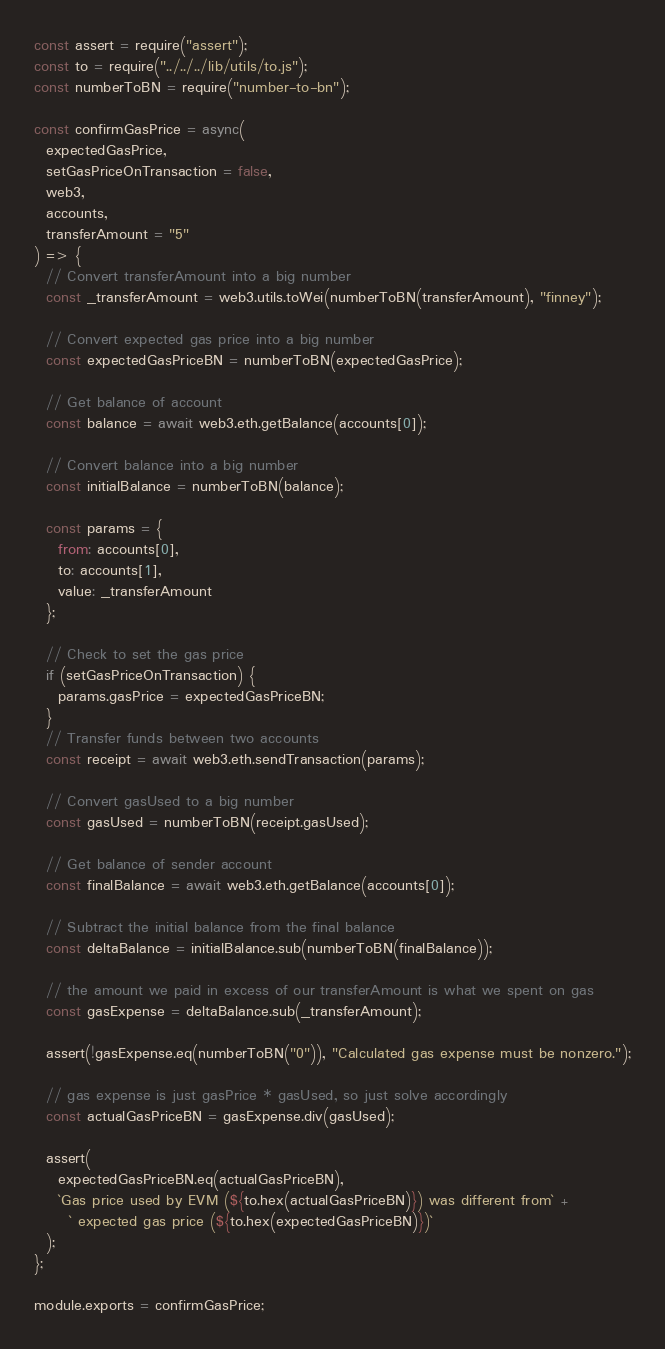<code> <loc_0><loc_0><loc_500><loc_500><_JavaScript_>const assert = require("assert");
const to = require("../../../lib/utils/to.js");
const numberToBN = require("number-to-bn");

const confirmGasPrice = async(
  expectedGasPrice,
  setGasPriceOnTransaction = false,
  web3,
  accounts,
  transferAmount = "5"
) => {
  // Convert transferAmount into a big number
  const _transferAmount = web3.utils.toWei(numberToBN(transferAmount), "finney");

  // Convert expected gas price into a big number
  const expectedGasPriceBN = numberToBN(expectedGasPrice);

  // Get balance of account
  const balance = await web3.eth.getBalance(accounts[0]);

  // Convert balance into a big number
  const initialBalance = numberToBN(balance);

  const params = {
    from: accounts[0],
    to: accounts[1],
    value: _transferAmount
  };

  // Check to set the gas price
  if (setGasPriceOnTransaction) {
    params.gasPrice = expectedGasPriceBN;
  }
  // Transfer funds between two accounts
  const receipt = await web3.eth.sendTransaction(params);

  // Convert gasUsed to a big number
  const gasUsed = numberToBN(receipt.gasUsed);

  // Get balance of sender account
  const finalBalance = await web3.eth.getBalance(accounts[0]);

  // Subtract the initial balance from the final balance
  const deltaBalance = initialBalance.sub(numberToBN(finalBalance));

  // the amount we paid in excess of our transferAmount is what we spent on gas
  const gasExpense = deltaBalance.sub(_transferAmount);

  assert(!gasExpense.eq(numberToBN("0")), "Calculated gas expense must be nonzero.");

  // gas expense is just gasPrice * gasUsed, so just solve accordingly
  const actualGasPriceBN = gasExpense.div(gasUsed);

  assert(
    expectedGasPriceBN.eq(actualGasPriceBN),
    `Gas price used by EVM (${to.hex(actualGasPriceBN)}) was different from` +
      ` expected gas price (${to.hex(expectedGasPriceBN)})`
  );
};

module.exports = confirmGasPrice;
</code> 